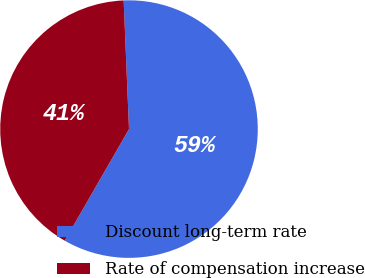Convert chart to OTSL. <chart><loc_0><loc_0><loc_500><loc_500><pie_chart><fcel>Discount long-term rate<fcel>Rate of compensation increase<nl><fcel>58.97%<fcel>41.03%<nl></chart> 